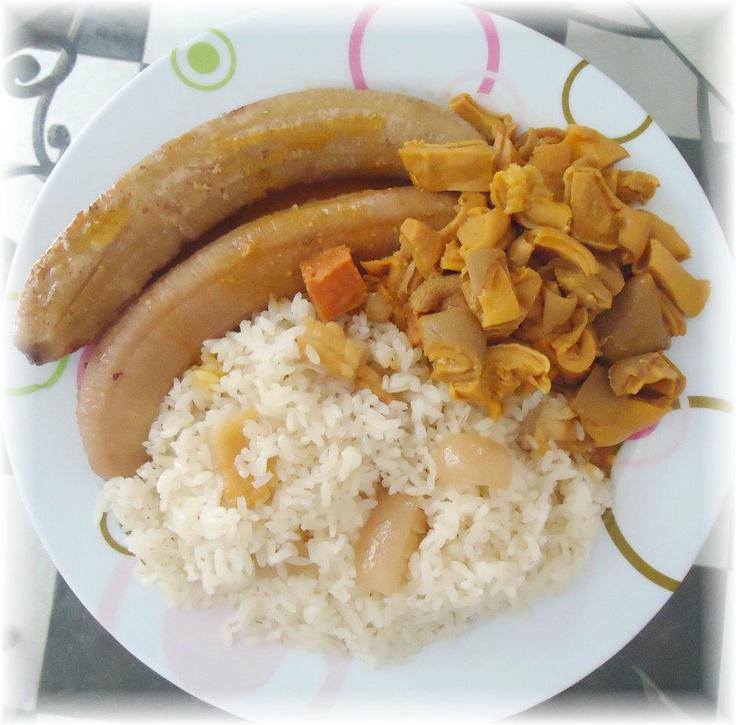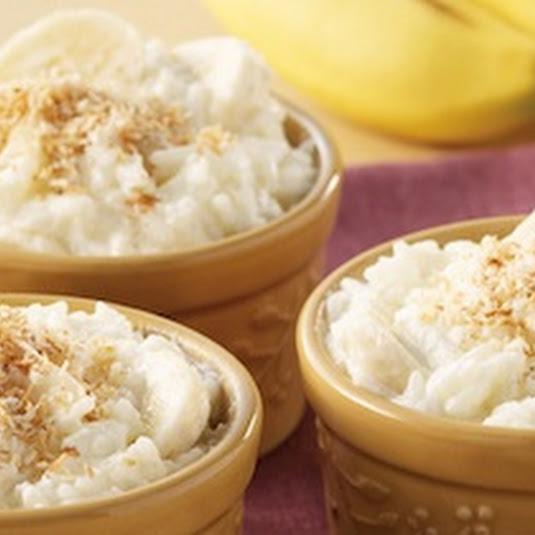The first image is the image on the left, the second image is the image on the right. Assess this claim about the two images: "An image shows exactly one round bowl that contains something creamy and whitish with brown spice sprinkled on top, and no other ingredients.". Correct or not? Answer yes or no. No. The first image is the image on the left, the second image is the image on the right. For the images displayed, is the sentence "All the food items are in bowls." factually correct? Answer yes or no. No. 